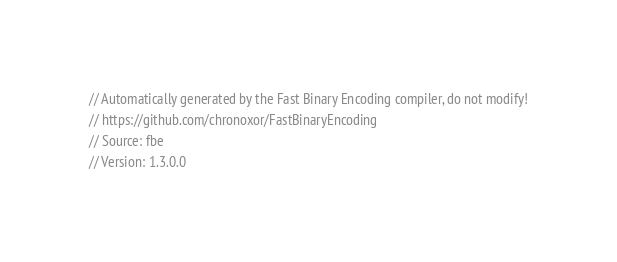Convert code to text. <code><loc_0><loc_0><loc_500><loc_500><_Kotlin_>// Automatically generated by the Fast Binary Encoding compiler, do not modify!
// https://github.com/chronoxor/FastBinaryEncoding
// Source: fbe
// Version: 1.3.0.0
</code> 